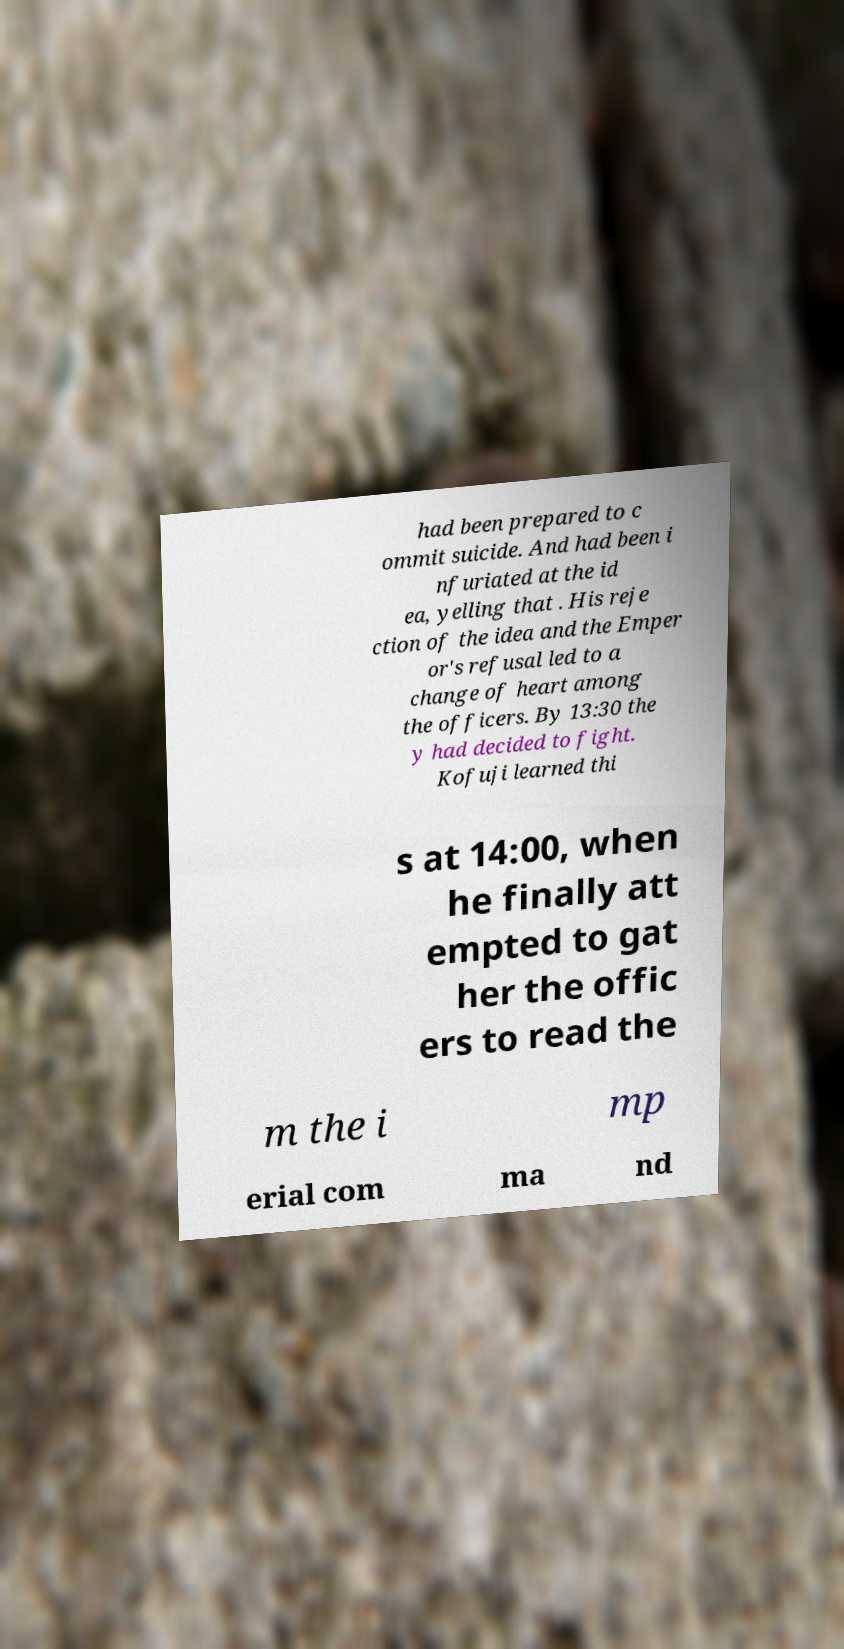What messages or text are displayed in this image? I need them in a readable, typed format. had been prepared to c ommit suicide. And had been i nfuriated at the id ea, yelling that . His reje ction of the idea and the Emper or's refusal led to a change of heart among the officers. By 13:30 the y had decided to fight. Kofuji learned thi s at 14:00, when he finally att empted to gat her the offic ers to read the m the i mp erial com ma nd 